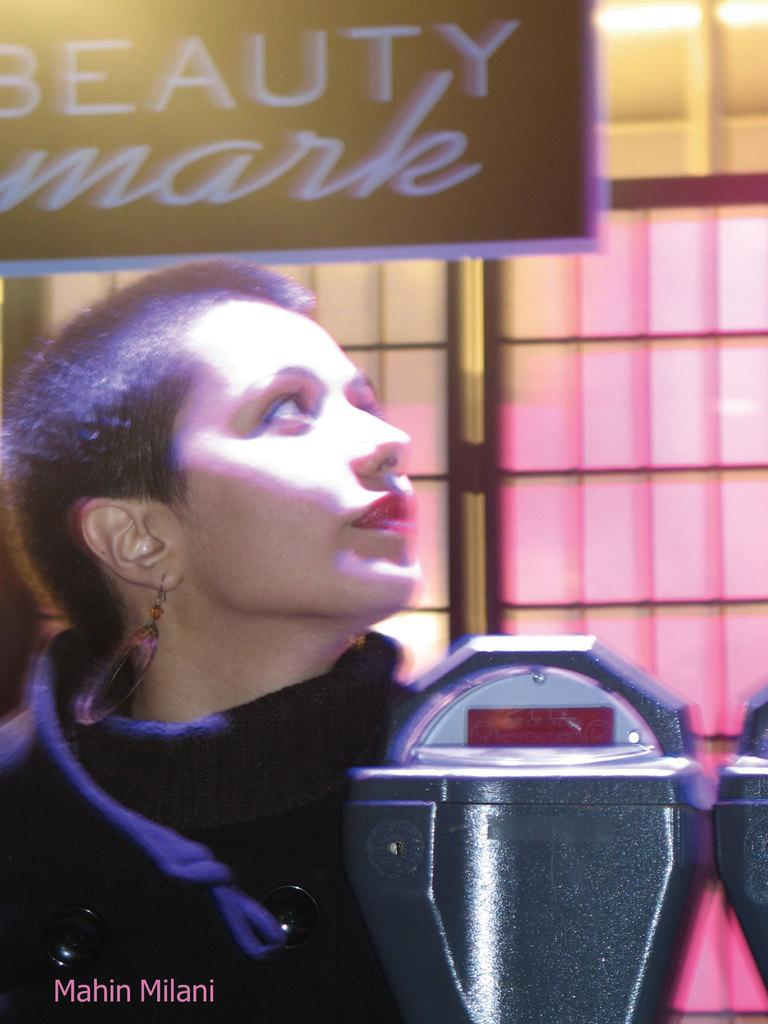Who is present in the image? There is a woman in the image. What is located beside the woman? There are objects beside the woman. What can be seen in the background of the image? There is a window in the image. What is written or displayed on the board in the image? There is a board with text in the image. What type of spade is being used by the woman in the image? There is no spade present in the image. Can you describe the kiss between the woman and the man in the image? There is no man or kiss present in the image; it only features a woman. 